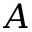Convert formula to latex. <formula><loc_0><loc_0><loc_500><loc_500>A</formula> 